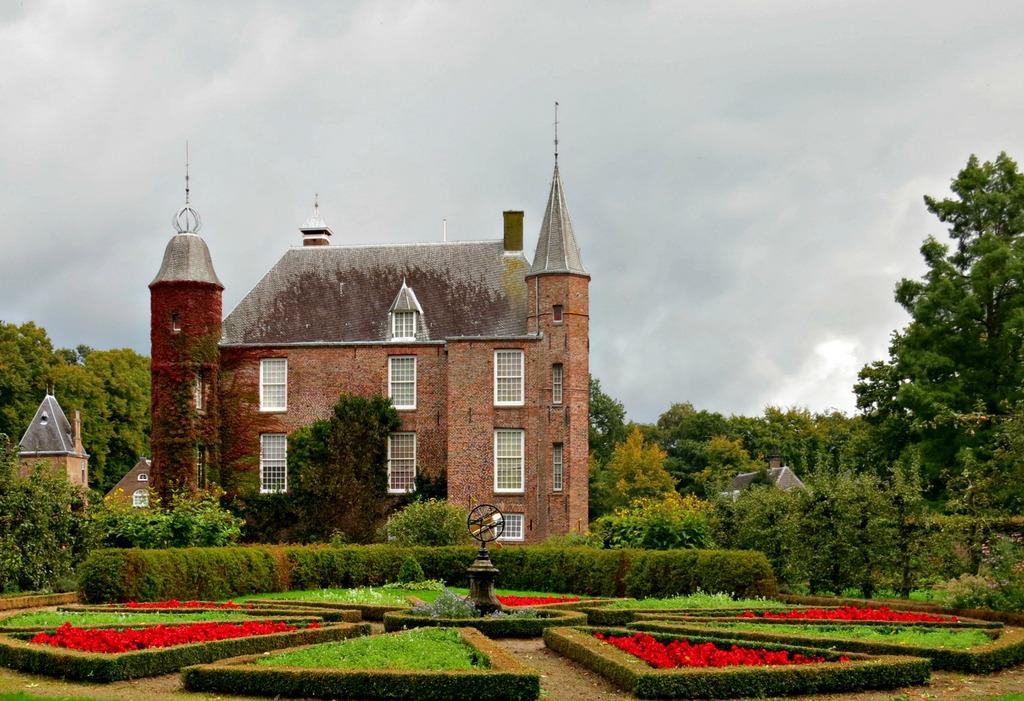What type of plants can be seen in the image? There are flowers, bushes, and trees in the image. What type of structures are present in the image? There are buildings in the image. What architectural feature can be seen on the buildings? There are windows visible on the buildings. What is visible in the sky in the image? There are clouds in the image, and the sky is visible. How many jellyfish can be seen swimming in the image? There are no jellyfish present in the image; it features plants, structures, and clouds. What type of wrist accessory is visible on the trees in the image? There are no wrist accessories present on the trees in the image; it features plants, structures, and clouds. 